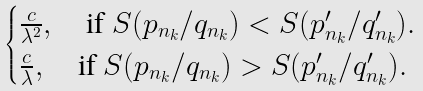<formula> <loc_0><loc_0><loc_500><loc_500>\begin{cases} \frac { c } { \lambda ^ { 2 } } , \quad \text {if } S ( p _ { n _ { k } } / q _ { n _ { k } } ) < S ( p ^ { \prime } _ { n _ { k } } / q ^ { \prime } _ { n _ { k } } ) . \\ \frac { c } { \lambda } , \quad \text {if } S ( p _ { n _ { k } } / q _ { n _ { k } } ) > S ( p ^ { \prime } _ { n _ { k } } / q ^ { \prime } _ { n _ { k } } ) . \end{cases}</formula> 